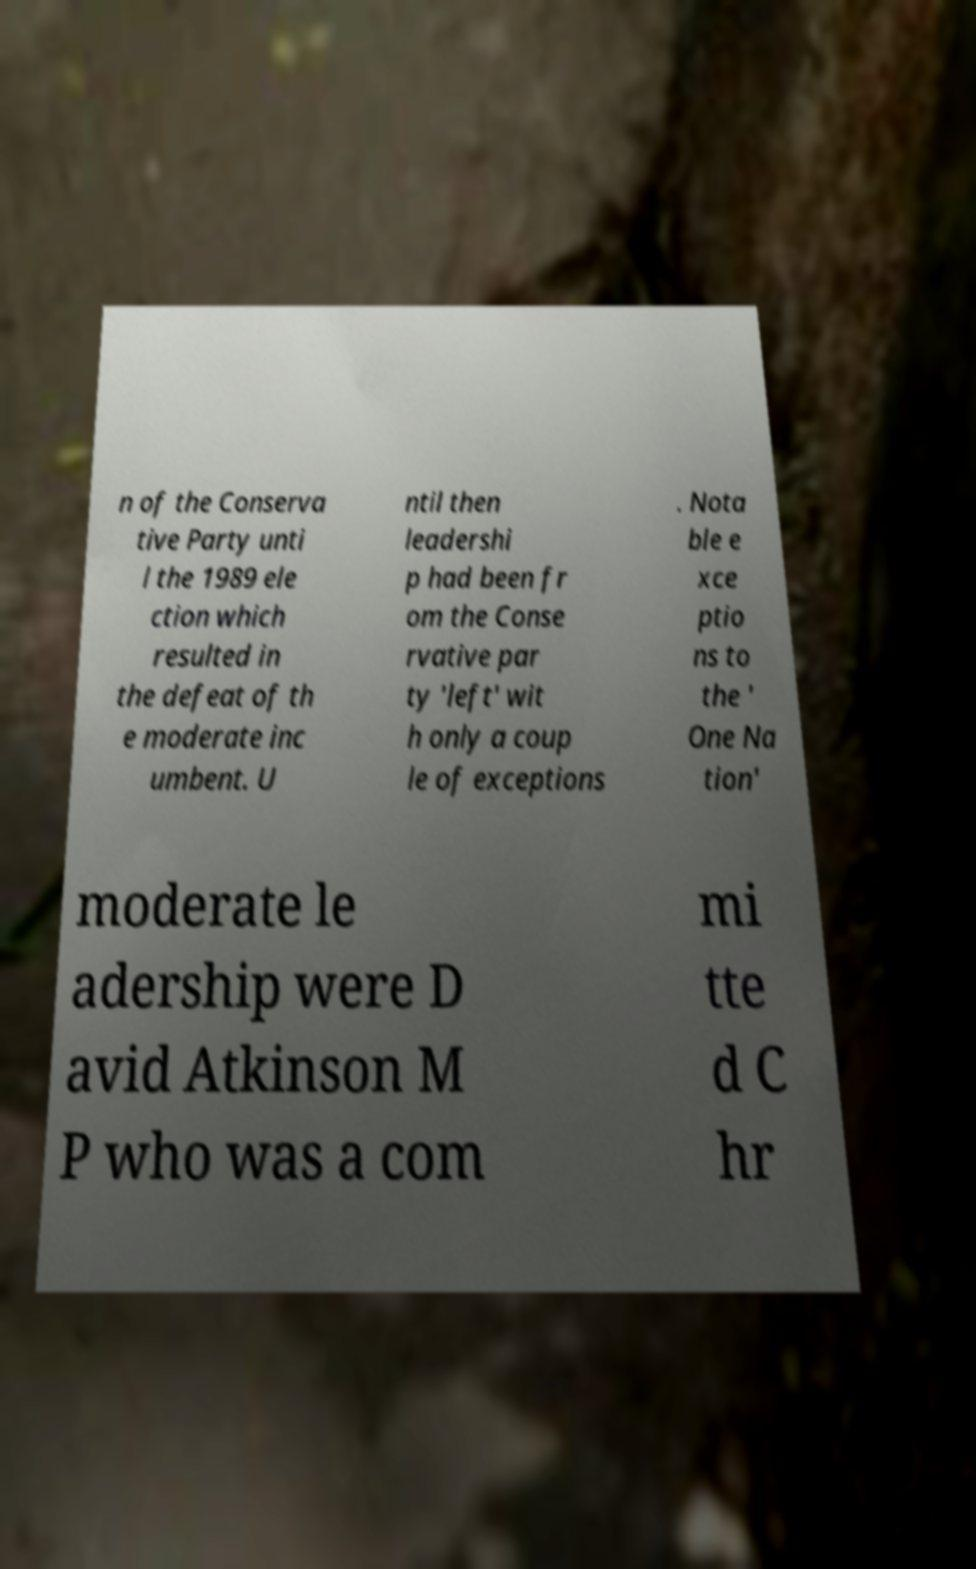Can you accurately transcribe the text from the provided image for me? n of the Conserva tive Party unti l the 1989 ele ction which resulted in the defeat of th e moderate inc umbent. U ntil then leadershi p had been fr om the Conse rvative par ty 'left' wit h only a coup le of exceptions . Nota ble e xce ptio ns to the ' One Na tion' moderate le adership were D avid Atkinson M P who was a com mi tte d C hr 